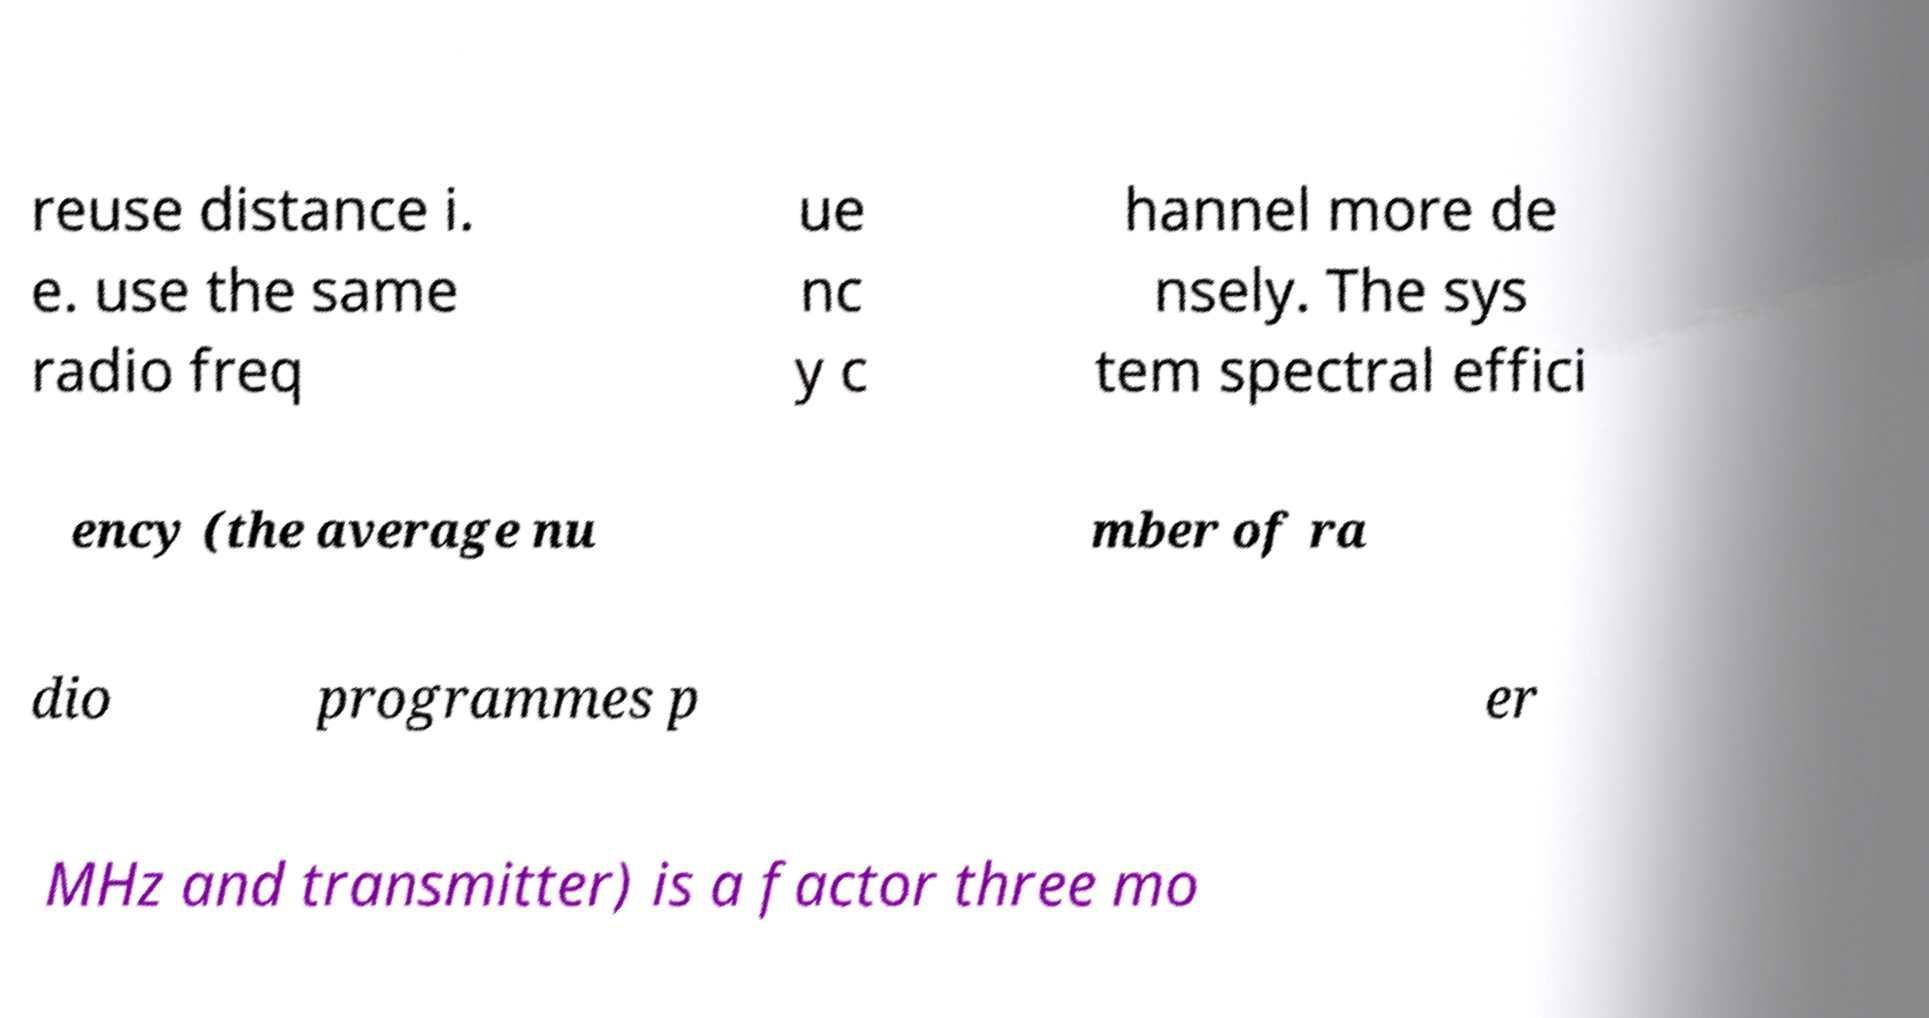Please read and relay the text visible in this image. What does it say? reuse distance i. e. use the same radio freq ue nc y c hannel more de nsely. The sys tem spectral effici ency (the average nu mber of ra dio programmes p er MHz and transmitter) is a factor three mo 